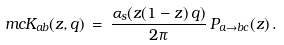<formula> <loc_0><loc_0><loc_500><loc_500>\ m c { K } _ { a b } ( z , q ) \, = \, \frac { \alpha _ { s } ( z ( 1 - z ) \, q ) } { 2 \pi } \, P _ { a \to b c } ( z ) \, .</formula> 